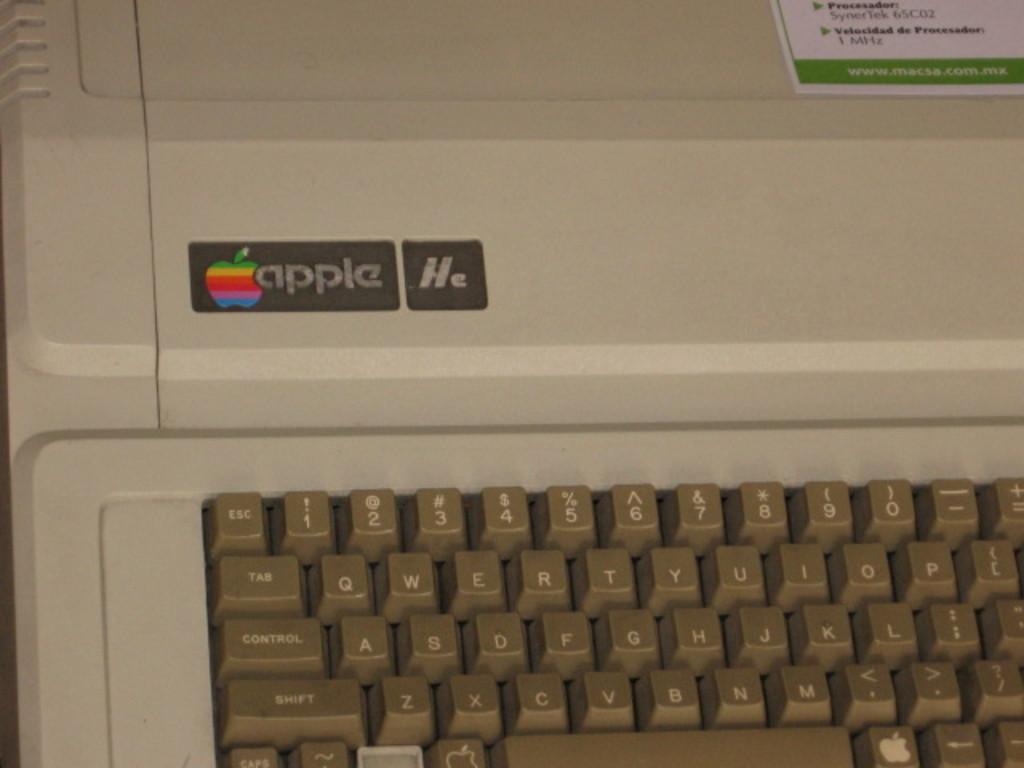What brand is the computer?
Make the answer very short. Apple. What is written on the key on the top left of the keyboard?
Give a very brief answer. Apple. 